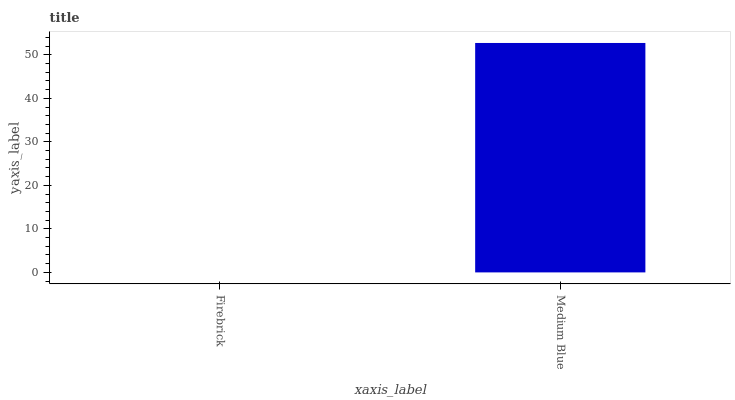Is Firebrick the minimum?
Answer yes or no. Yes. Is Medium Blue the maximum?
Answer yes or no. Yes. Is Medium Blue the minimum?
Answer yes or no. No. Is Medium Blue greater than Firebrick?
Answer yes or no. Yes. Is Firebrick less than Medium Blue?
Answer yes or no. Yes. Is Firebrick greater than Medium Blue?
Answer yes or no. No. Is Medium Blue less than Firebrick?
Answer yes or no. No. Is Medium Blue the high median?
Answer yes or no. Yes. Is Firebrick the low median?
Answer yes or no. Yes. Is Firebrick the high median?
Answer yes or no. No. Is Medium Blue the low median?
Answer yes or no. No. 